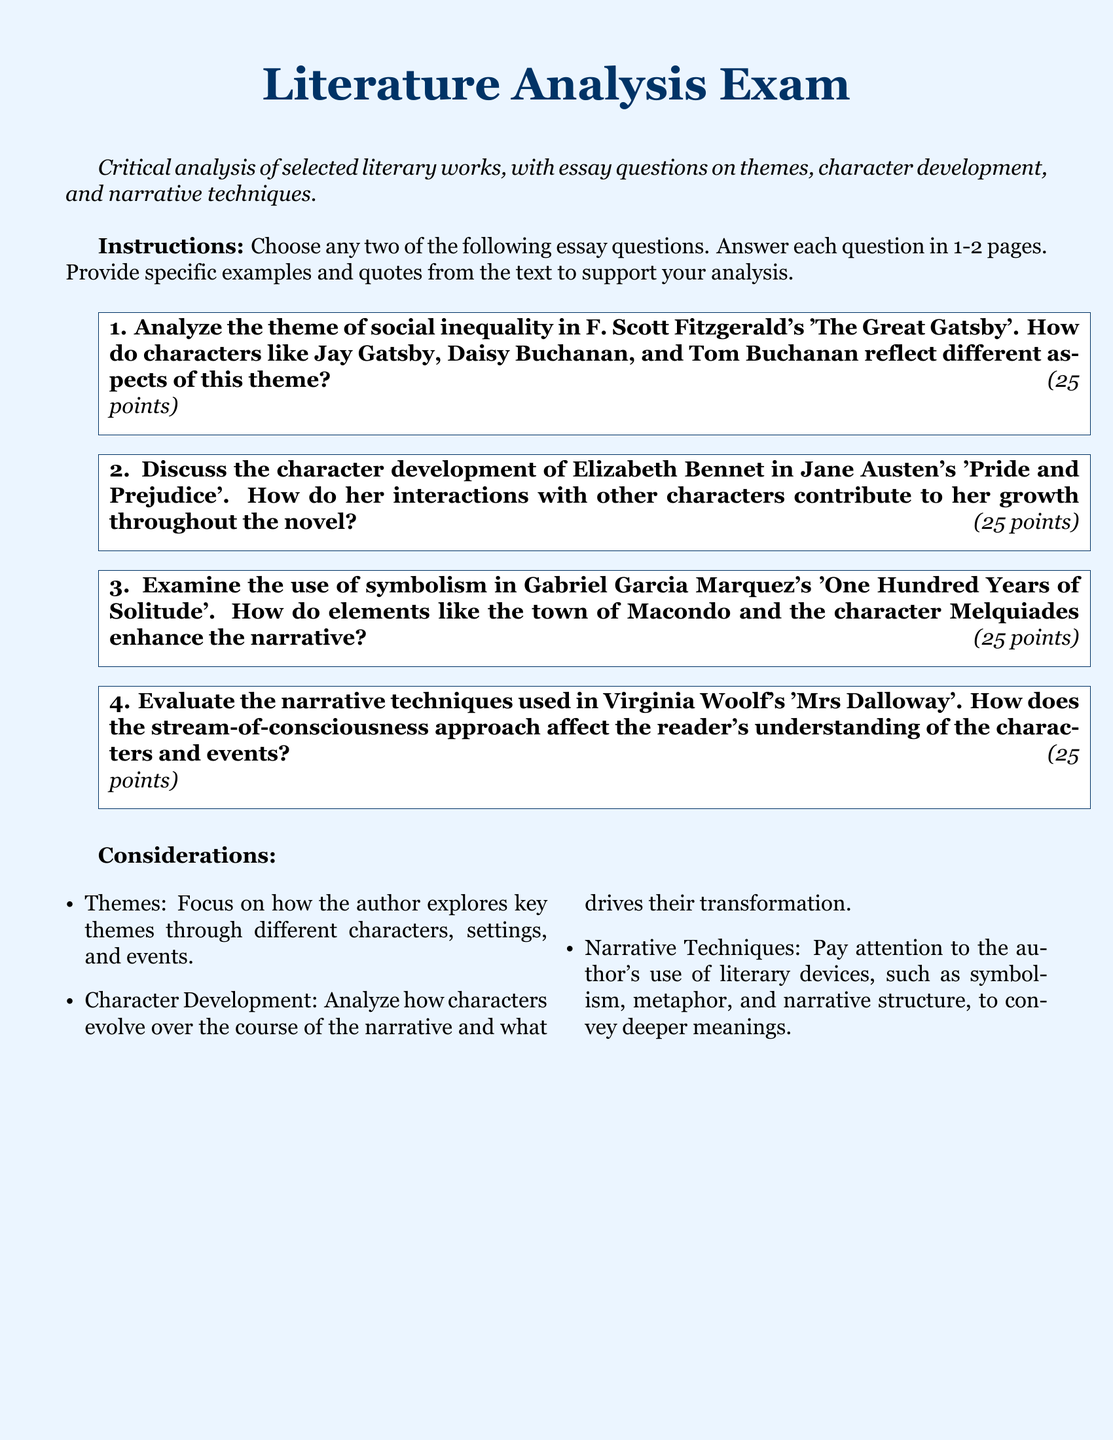what is the title of the exam? The title of the exam is explicitly stated at the top of the document.
Answer: Literature Analysis Exam how many essay questions are provided? The document lists a total of four essay questions for the exam.
Answer: four who is the author of 'Pride and Prejudice'? The literary work mentioned in the document is attributed to a specific author.
Answer: Jane Austen what is the point value for each essay question? Each essay question has the same point value given in the document.
Answer: 25 which narrative technique is evaluated in 'Mrs Dalloway'? The document specifies a particular narrative technique that is the focus of the essay question related to this literary work.
Answer: stream-of-consciousness what are the specific areas to focus on in the analysis? The document lists considerations that detail what to focus on but provides only a few key aspects.
Answer: Themes, Character Development, Narrative Techniques 